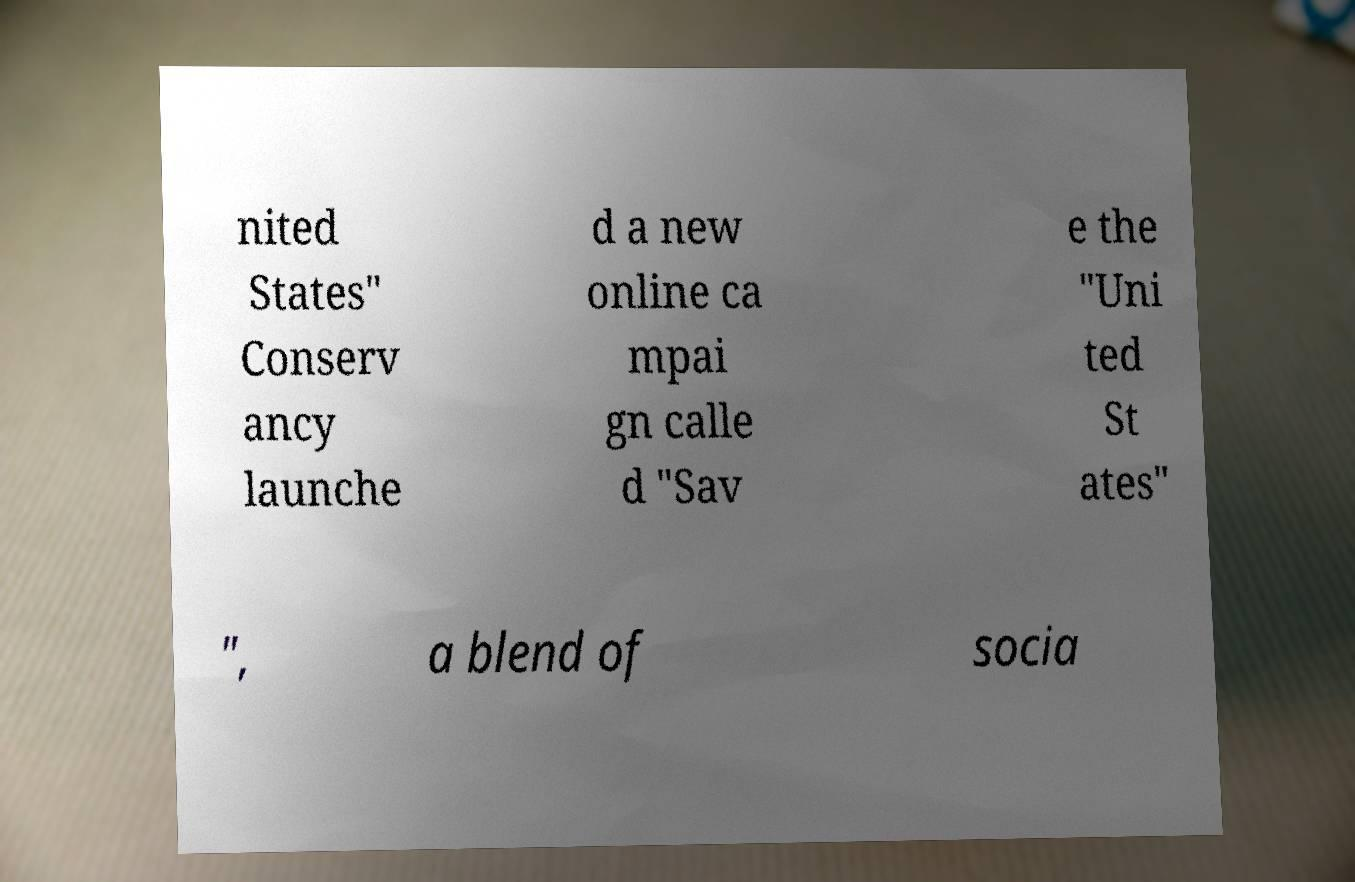Please identify and transcribe the text found in this image. nited States" Conserv ancy launche d a new online ca mpai gn calle d "Sav e the "Uni ted St ates" ", a blend of socia 